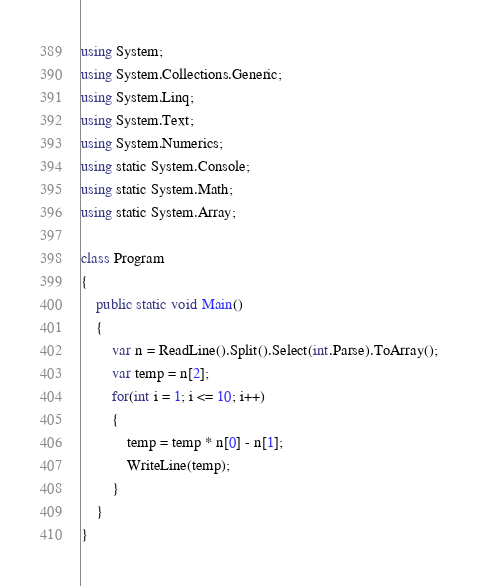<code> <loc_0><loc_0><loc_500><loc_500><_C#_>using System;
using System.Collections.Generic;
using System.Linq;
using System.Text;
using System.Numerics;
using static System.Console;
using static System.Math;
using static System.Array;

class Program
{
    public static void Main()
    {
        var n = ReadLine().Split().Select(int.Parse).ToArray();
        var temp = n[2];
        for(int i = 1; i <= 10; i++)
        {
            temp = temp * n[0] - n[1];
            WriteLine(temp);
        }
    }
}
</code> 